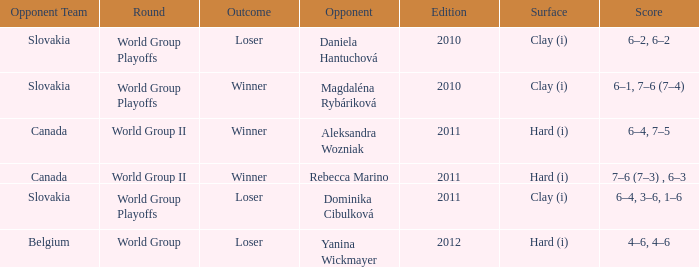What was the game edition when they played on the clay (i) surface and the outcome was a winner? 2010.0. 